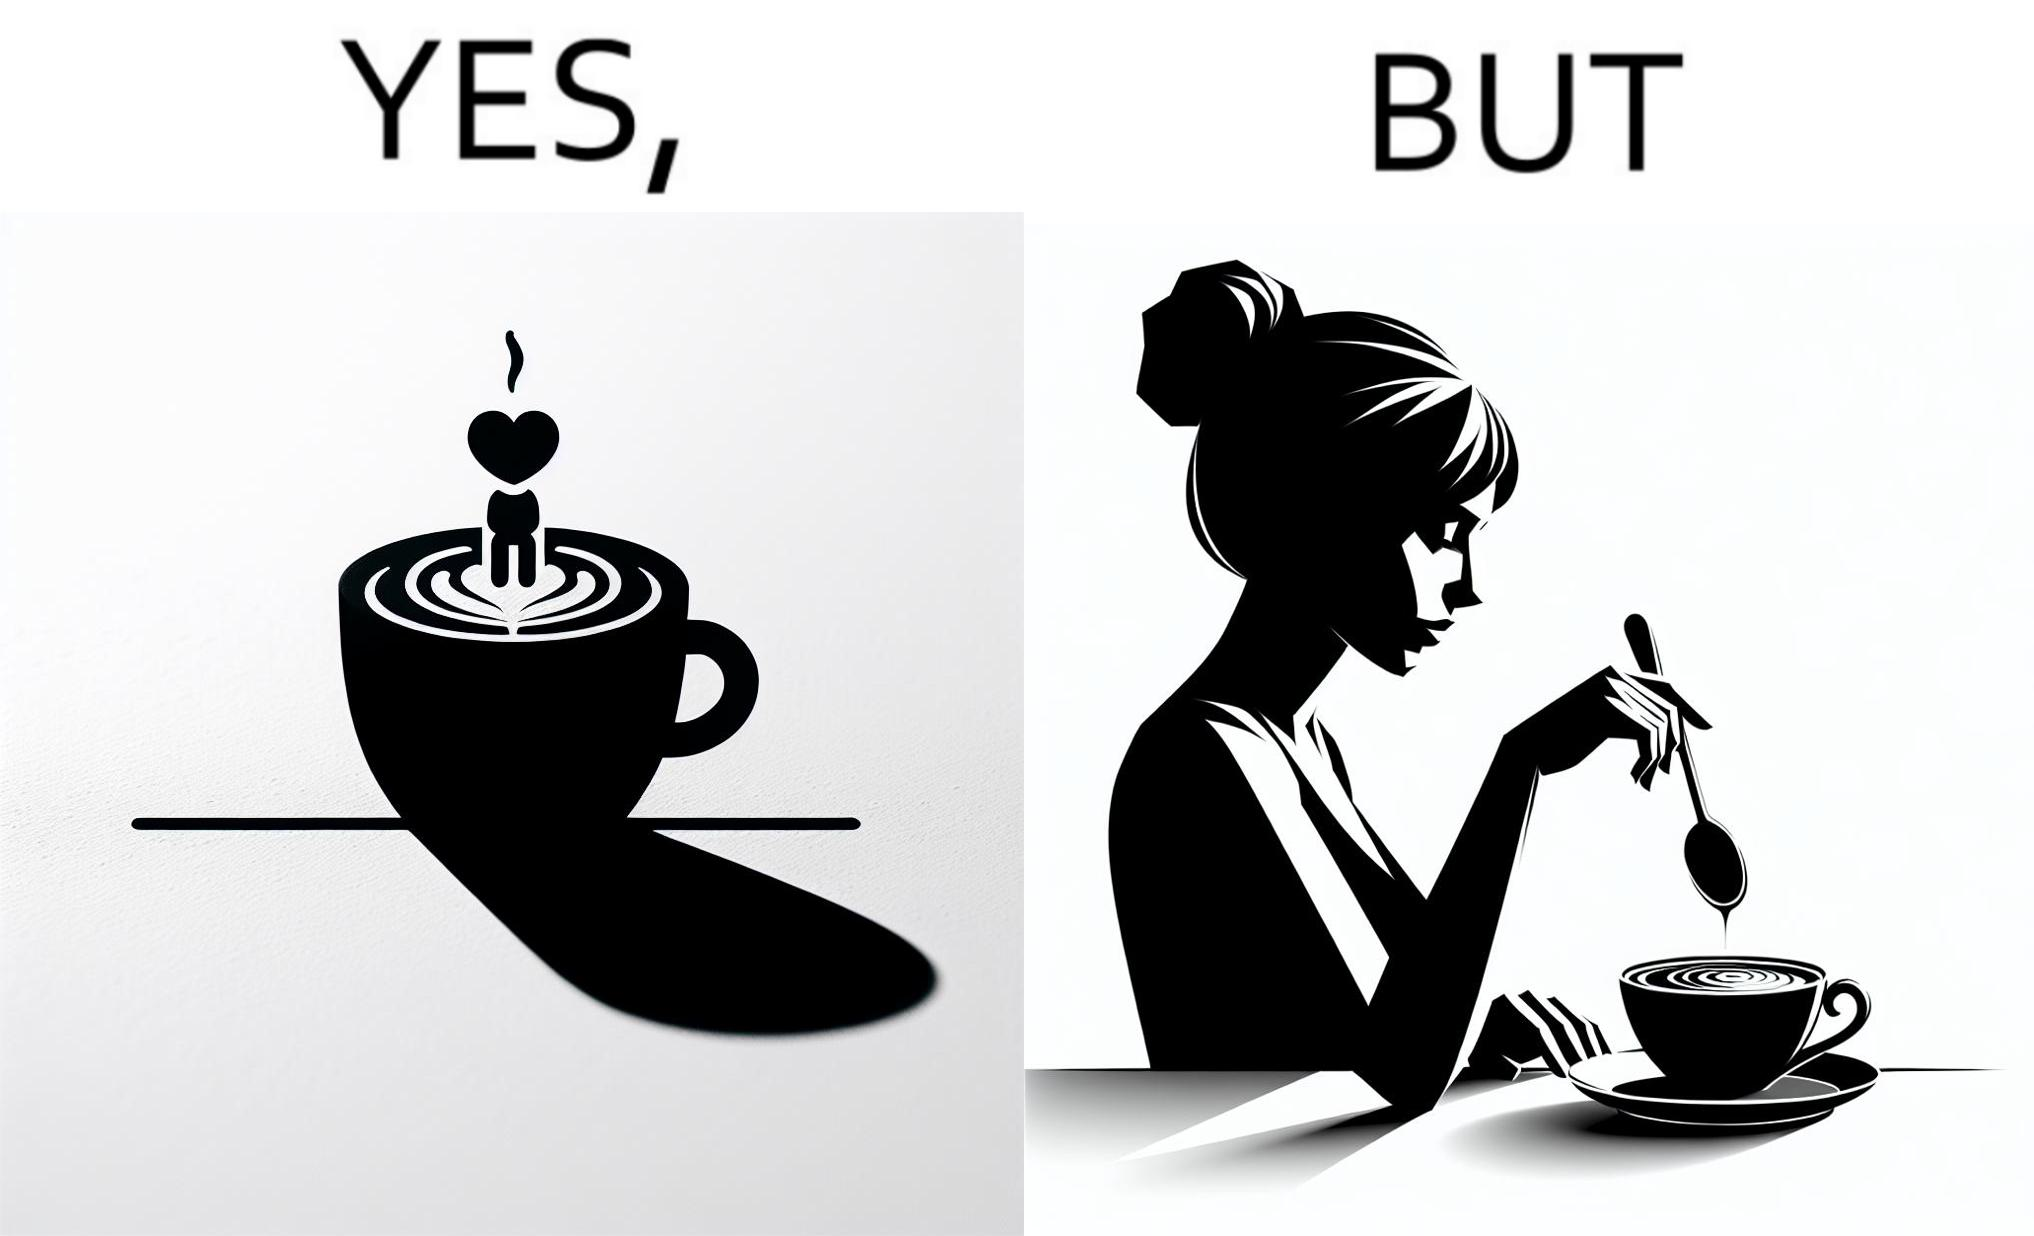Is there satirical content in this image? Yes, this image is satirical. 